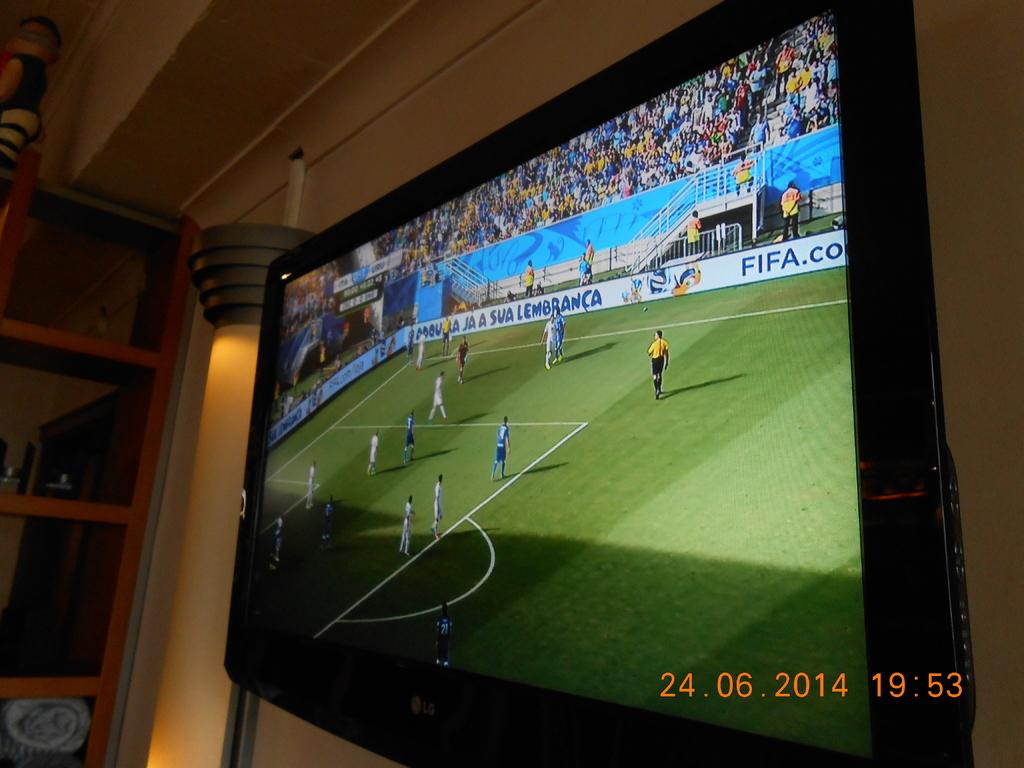Provide a one-sentence caption for the provided image. The picture was taken on June 24, 2014. 